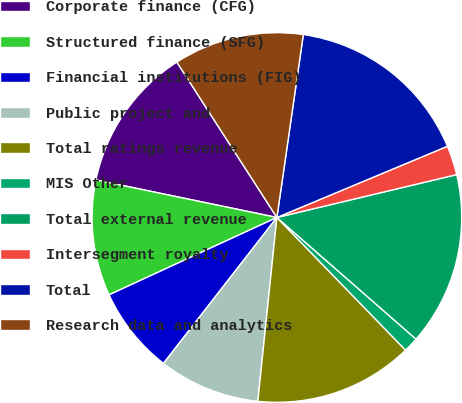Convert chart to OTSL. <chart><loc_0><loc_0><loc_500><loc_500><pie_chart><fcel>Corporate finance (CFG)<fcel>Structured finance (SFG)<fcel>Financial institutions (FIG)<fcel>Public project and<fcel>Total ratings revenue<fcel>MIS Other<fcel>Total external revenue<fcel>Intersegment royalty<fcel>Total<fcel>Research data and analytics<nl><fcel>12.64%<fcel>10.13%<fcel>7.61%<fcel>8.87%<fcel>13.9%<fcel>1.31%<fcel>15.16%<fcel>2.57%<fcel>16.42%<fcel>11.39%<nl></chart> 